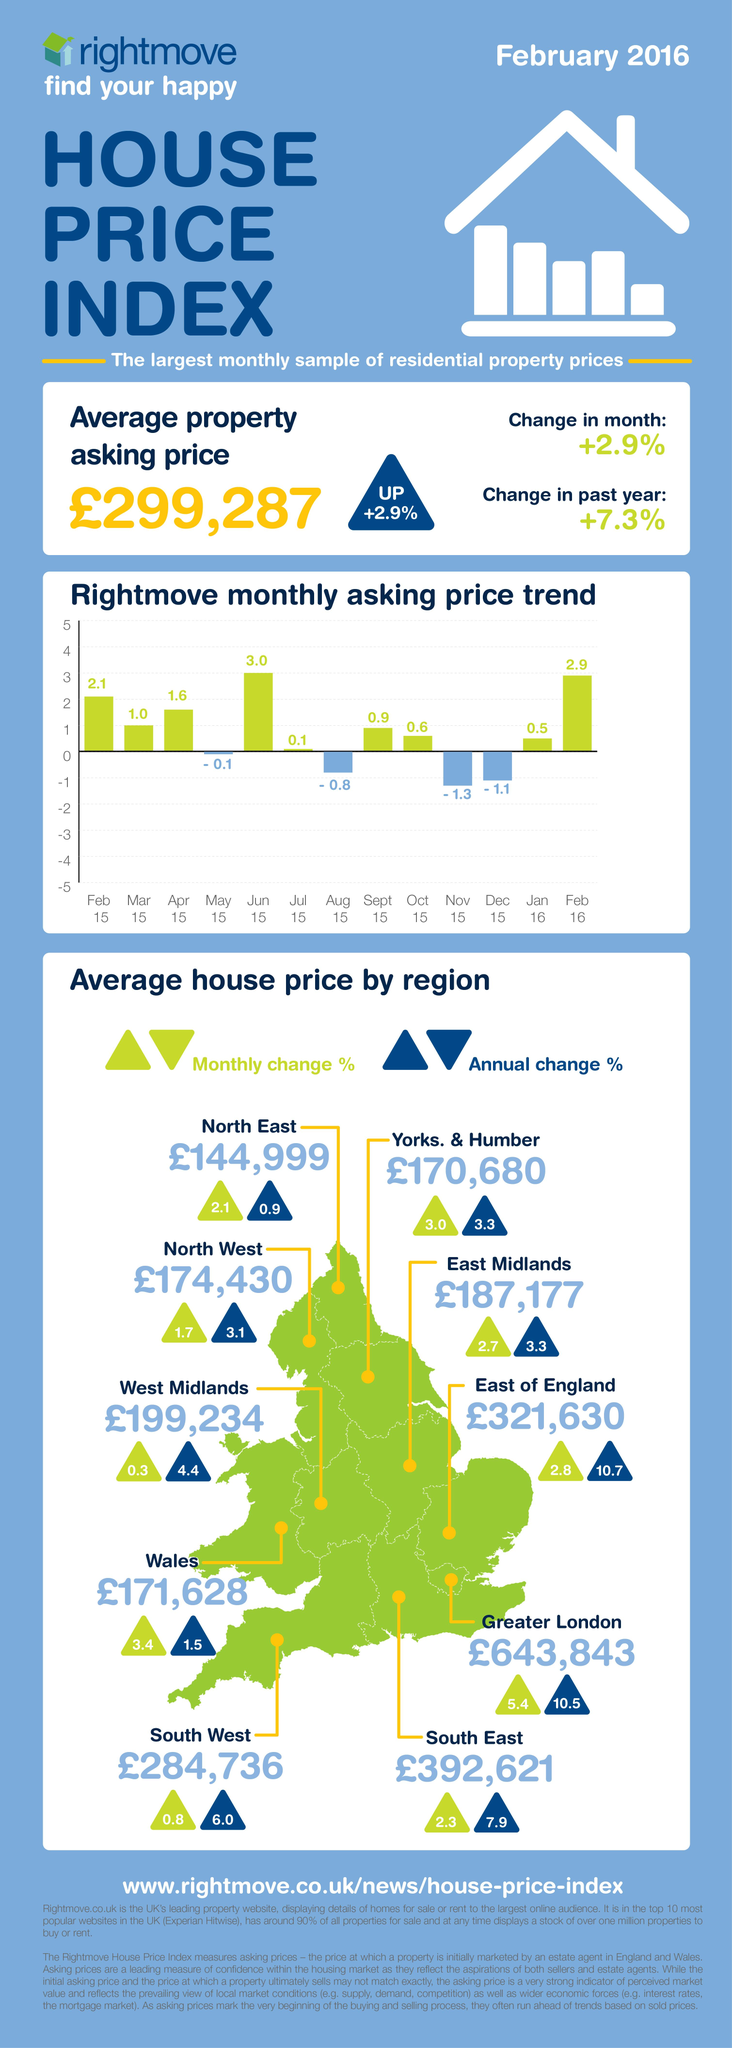Highlight a few significant elements in this photo. The average house price in Wales underwent an annual change percentage of 1.5% during the specified time period. The East of England region in the United Kingdom has the highest annual change percentage of the average house price, according to data. The average house price in the North East of the UK has experienced a monthly increase of 2.1% over the past month. The North East region of the United Kingdom has the lowest annual change percentage of the average house price, meaning that the price of houses in this region has increased at the lowest rate compared to the other regions in the UK. As of February 2016, the average house price in the East Midlands was £187,177. 